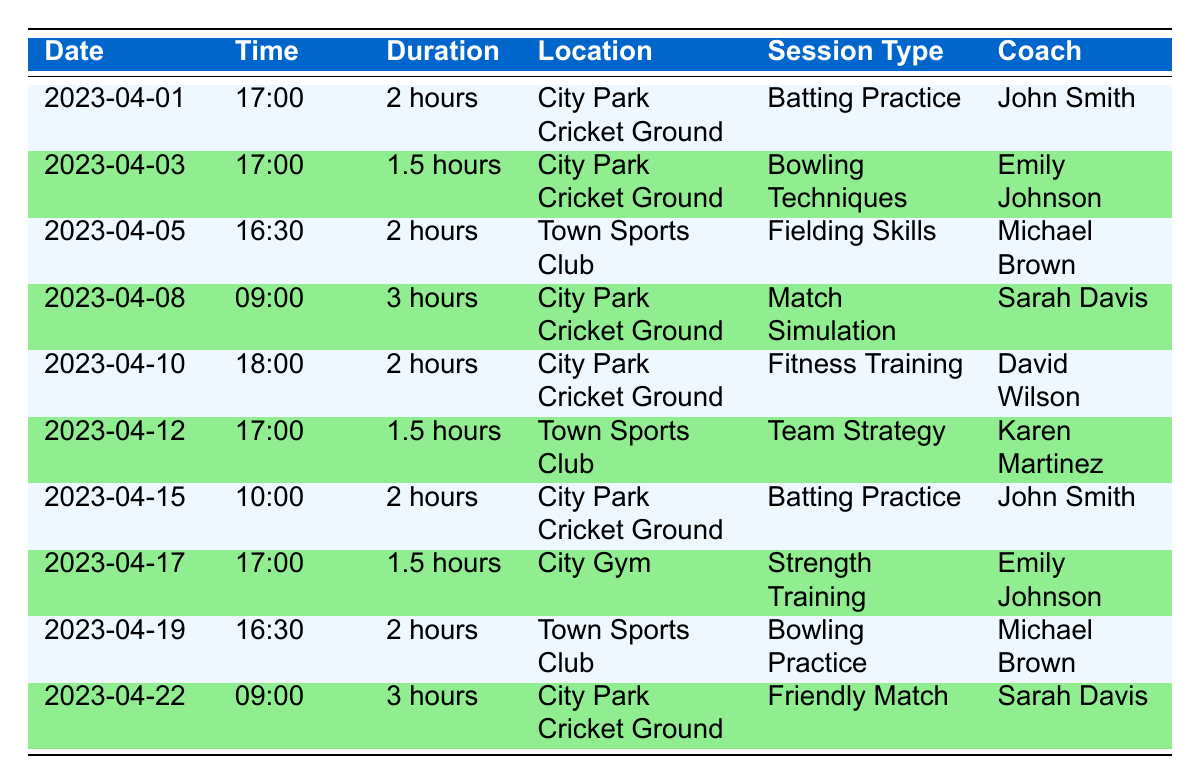What is the location of the session on April 10, 2023? The session scheduled for April 10, 2023, is located at the City Park Cricket Ground. This information can be found by looking directly at the row for that date in the table.
Answer: City Park Cricket Ground Who is the coach for the Battery Practice on April 15, 2023? The coach for the Batting Practice on April 15, 2023, is John Smith. This can be verified from the corresponding row in the table.
Answer: John Smith How many hours is the Match Simulation session on April 8, 2023? The Match Simulation session on April 8, 2023, has a duration of 3 hours. This is specified in the duration column of that row in the table.
Answer: 3 hours What are the different types of sessions occurring at City Park Cricket Ground? The different types of sessions at City Park Cricket Ground from the table are Batting Practice, Match Simulation, and Fitness Training. Searching through the location column, we can extract the unique session types for that venue.
Answer: Batting Practice, Match Simulation, Fitness Training Is there a session titled "Team Strategy" taking place at the City Gym? No, there is no session titled "Team Strategy" scheduled at the City Gym. The table indicates that the "Team Strategy" session is held at Town Sports Club, while the only sessions at City Gym are "Strength Training."
Answer: No What is the average duration of the training sessions held at Town Sports Club? There are three sessions held at Town Sports Club with the durations of 2 hours, 1.5 hours, and 2 hours. To find the average, we sum these durations: 2 + 1.5 + 2 = 5.5 hours. There are three sessions, thus the average duration is 5.5 / 3 = 1.83 hours, or approximately 1 hour and 50 minutes.
Answer: 1.83 hours How many different coaches are leading the training sessions? The table provides five coaches: John Smith, Emily Johnson, Michael Brown, Sarah Davis, and David Wilson. None are repeated, thus we count each one to find that there are five distinct coaches.
Answer: 5 coaches What is the total duration of all training sessions scheduled after April 10, 2023? The training sessions after April 10, 2023, show durations of 1.5 hours (April 12), 2 hours (April 15), 1.5 hours (April 17), 2 hours (April 19), and 3 hours (April 22). We sum these durations: 1.5 + 2 + 1.5 + 2 + 3 = 10 hours. This gives us the total duration of training sessions scheduled after April 10, 2023.
Answer: 10 hours 